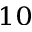Convert formula to latex. <formula><loc_0><loc_0><loc_500><loc_500>_ { 1 0 }</formula> 